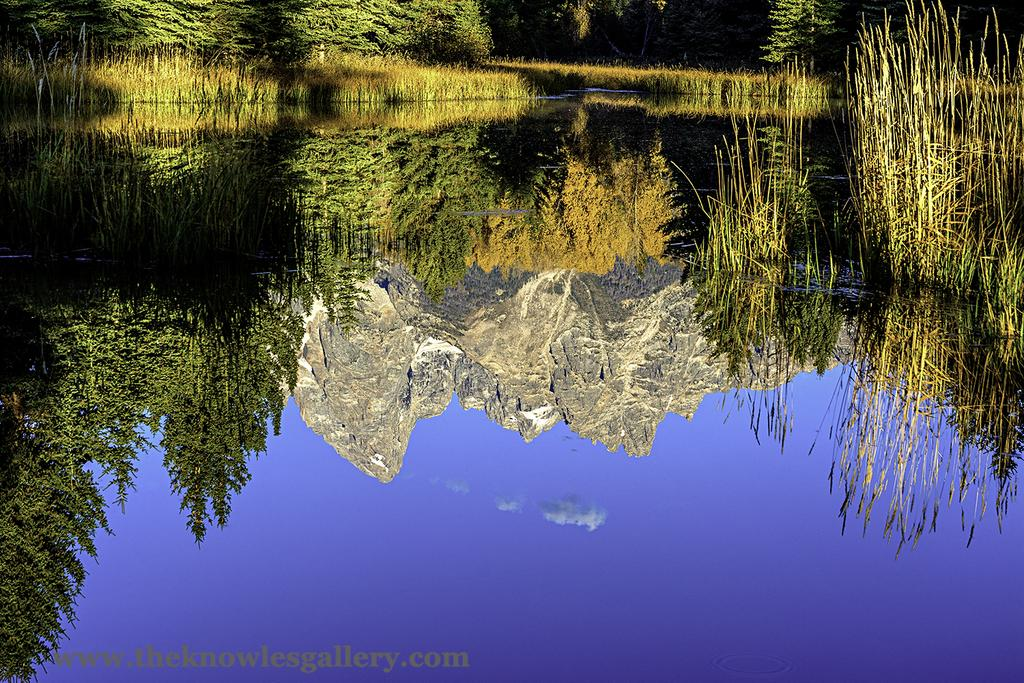What is one of the main elements in the image? There is water in the image. What type of vegetation can be seen in the image? There is grass in the image. What can be seen in the reflection on the water? There is a reflection of trees and mountains in the water, as well as the sky. Where is the squirrel hiding in the image? There is no squirrel present in the image. What is the fifth element in the image? The provided facts do not mention a fifth element in the image. 